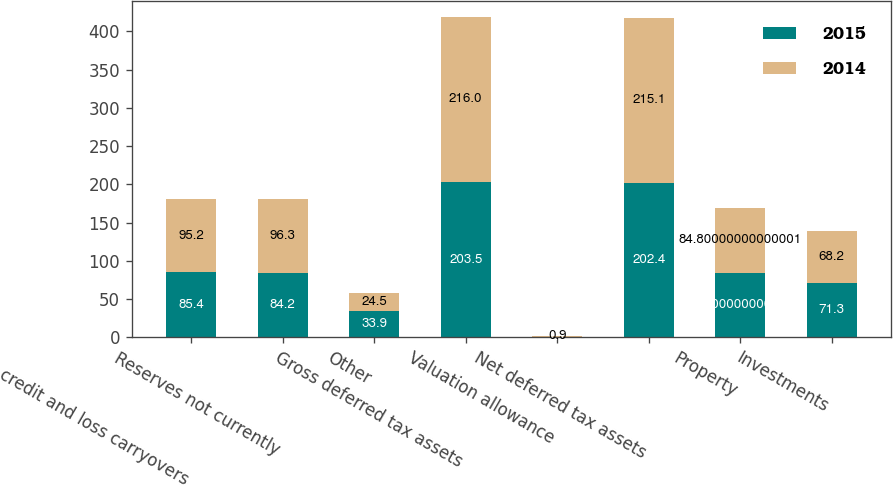<chart> <loc_0><loc_0><loc_500><loc_500><stacked_bar_chart><ecel><fcel>Tax credit and loss carryovers<fcel>Reserves not currently<fcel>Other<fcel>Gross deferred tax assets<fcel>Valuation allowance<fcel>Net deferred tax assets<fcel>Property<fcel>Investments<nl><fcel>2015<fcel>85.4<fcel>84.2<fcel>33.9<fcel>203.5<fcel>1.1<fcel>202.4<fcel>84.8<fcel>71.3<nl><fcel>2014<fcel>95.2<fcel>96.3<fcel>24.5<fcel>216<fcel>0.9<fcel>215.1<fcel>84.8<fcel>68.2<nl></chart> 